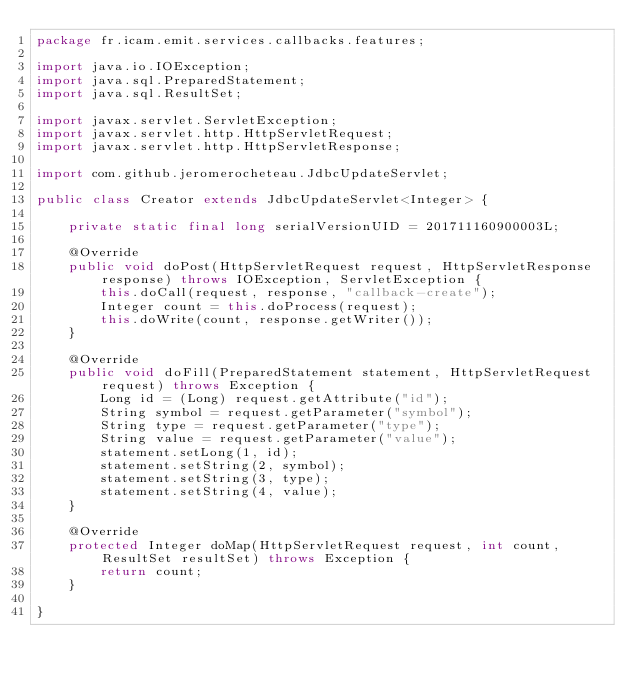<code> <loc_0><loc_0><loc_500><loc_500><_Java_>package fr.icam.emit.services.callbacks.features;

import java.io.IOException;
import java.sql.PreparedStatement;
import java.sql.ResultSet;

import javax.servlet.ServletException;
import javax.servlet.http.HttpServletRequest;
import javax.servlet.http.HttpServletResponse;

import com.github.jeromerocheteau.JdbcUpdateServlet;

public class Creator extends JdbcUpdateServlet<Integer> {

	private static final long serialVersionUID = 201711160900003L;

	@Override
	public void doPost(HttpServletRequest request, HttpServletResponse response) throws IOException, ServletException {
		this.doCall(request, response, "callback-create");
		Integer count = this.doProcess(request);
		this.doWrite(count, response.getWriter());
	}

	@Override
	public void doFill(PreparedStatement statement, HttpServletRequest request) throws Exception {
		Long id = (Long) request.getAttribute("id");
		String symbol = request.getParameter("symbol");
		String type = request.getParameter("type");
		String value = request.getParameter("value");
		statement.setLong(1, id);
		statement.setString(2, symbol);
		statement.setString(3, type);
		statement.setString(4, value);
	}
	
	@Override
	protected Integer doMap(HttpServletRequest request, int count, ResultSet resultSet) throws Exception {
		return count;
	}

}
</code> 